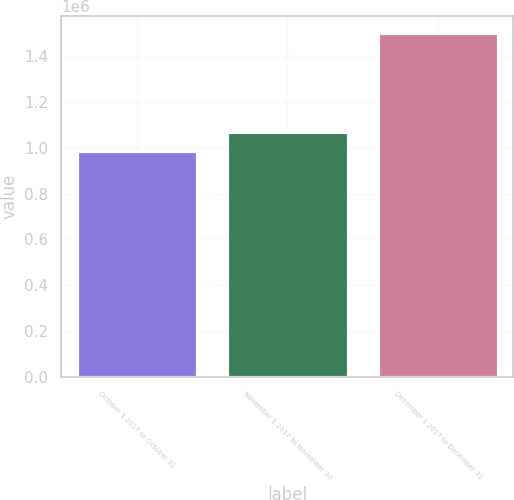Convert chart to OTSL. <chart><loc_0><loc_0><loc_500><loc_500><bar_chart><fcel>October 1 2017 to October 31<fcel>November 1 2017 to November 30<fcel>December 1 2017 to December 31<nl><fcel>986175<fcel>1.06884e+06<fcel>1.49961e+06<nl></chart> 